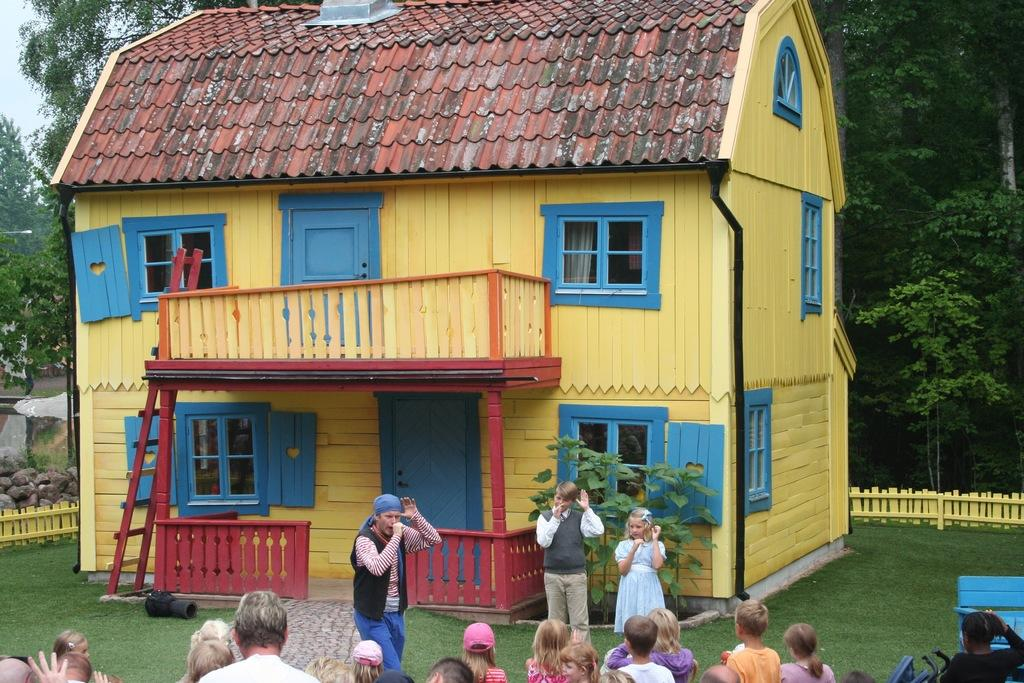How many people are in the image? There is a group of people in the image, but the exact number cannot be determined from the provided facts. What type of terrain is visible in the image? There is grass, plants, rocks, and trees in the image, suggesting a natural setting. What object might be used for climbing or reaching higher places? There is a ladder in the image, which can be used for climbing or reaching higher places. What structure is visible in the background of the image? There is a house in the image, which is visible in the background. What is visible in the sky in the image? The sky is visible in the background of the image, but no specific weather conditions or atmospheric phenomena are mentioned. What level of pollution can be seen in the image? There is no mention of pollution in the image, so it cannot be determined from the provided facts. What type of heat source is visible in the image? There is no heat source visible in the image, as it primarily features a group of people, plants, and a house. 